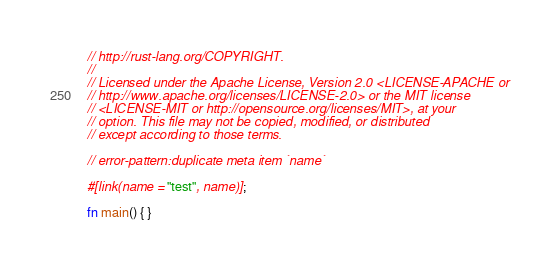Convert code to text. <code><loc_0><loc_0><loc_500><loc_500><_Rust_>// http://rust-lang.org/COPYRIGHT.
//
// Licensed under the Apache License, Version 2.0 <LICENSE-APACHE or
// http://www.apache.org/licenses/LICENSE-2.0> or the MIT license
// <LICENSE-MIT or http://opensource.org/licenses/MIT>, at your
// option. This file may not be copied, modified, or distributed
// except according to those terms.

// error-pattern:duplicate meta item `name`

#[link(name = "test", name)];

fn main() { }
</code> 